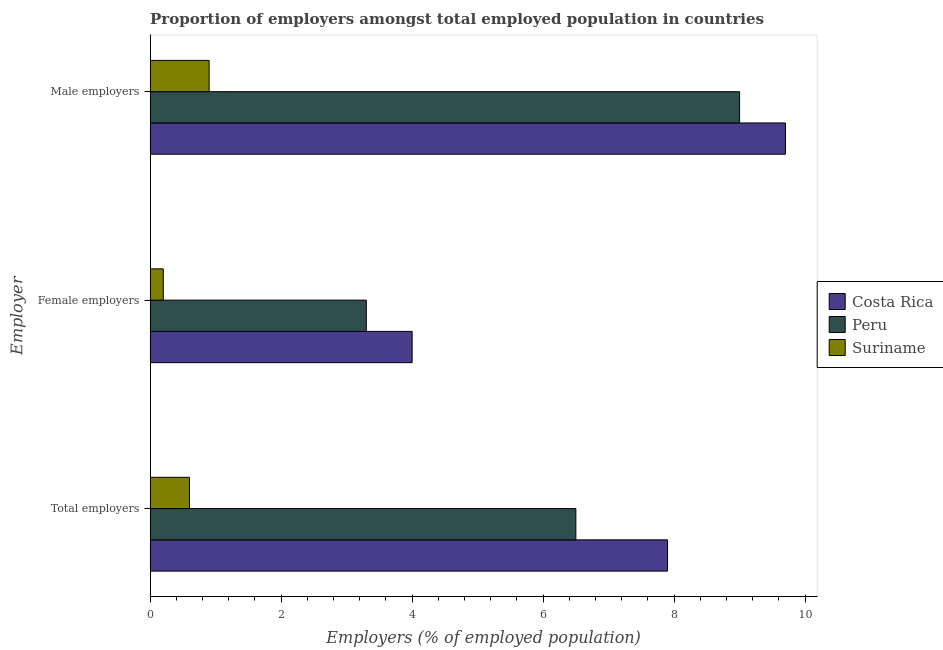How many different coloured bars are there?
Ensure brevity in your answer.  3. How many groups of bars are there?
Keep it short and to the point. 3. Are the number of bars per tick equal to the number of legend labels?
Make the answer very short. Yes. How many bars are there on the 3rd tick from the top?
Your answer should be very brief. 3. What is the label of the 3rd group of bars from the top?
Offer a very short reply. Total employers. Across all countries, what is the maximum percentage of total employers?
Provide a succinct answer. 7.9. Across all countries, what is the minimum percentage of female employers?
Provide a succinct answer. 0.2. In which country was the percentage of male employers maximum?
Ensure brevity in your answer.  Costa Rica. In which country was the percentage of male employers minimum?
Offer a very short reply. Suriname. What is the total percentage of male employers in the graph?
Offer a very short reply. 19.6. What is the difference between the percentage of total employers in Costa Rica and that in Peru?
Your answer should be compact. 1.4. What is the difference between the percentage of female employers in Peru and the percentage of male employers in Costa Rica?
Your answer should be compact. -6.4. What is the average percentage of female employers per country?
Offer a terse response. 2.5. What is the difference between the percentage of total employers and percentage of male employers in Peru?
Provide a short and direct response. -2.5. What is the ratio of the percentage of female employers in Suriname to that in Costa Rica?
Offer a terse response. 0.05. Is the difference between the percentage of female employers in Peru and Costa Rica greater than the difference between the percentage of male employers in Peru and Costa Rica?
Make the answer very short. No. What is the difference between the highest and the second highest percentage of total employers?
Your response must be concise. 1.4. What is the difference between the highest and the lowest percentage of male employers?
Provide a succinct answer. 8.8. What does the 1st bar from the top in Male employers represents?
Offer a very short reply. Suriname. Is it the case that in every country, the sum of the percentage of total employers and percentage of female employers is greater than the percentage of male employers?
Ensure brevity in your answer.  No. How many bars are there?
Provide a succinct answer. 9. Are the values on the major ticks of X-axis written in scientific E-notation?
Offer a very short reply. No. Does the graph contain any zero values?
Ensure brevity in your answer.  No. Does the graph contain grids?
Provide a succinct answer. No. Where does the legend appear in the graph?
Your response must be concise. Center right. How many legend labels are there?
Offer a very short reply. 3. What is the title of the graph?
Ensure brevity in your answer.  Proportion of employers amongst total employed population in countries. What is the label or title of the X-axis?
Ensure brevity in your answer.  Employers (% of employed population). What is the label or title of the Y-axis?
Offer a terse response. Employer. What is the Employers (% of employed population) in Costa Rica in Total employers?
Keep it short and to the point. 7.9. What is the Employers (% of employed population) in Peru in Total employers?
Make the answer very short. 6.5. What is the Employers (% of employed population) of Suriname in Total employers?
Make the answer very short. 0.6. What is the Employers (% of employed population) in Costa Rica in Female employers?
Your answer should be very brief. 4. What is the Employers (% of employed population) of Peru in Female employers?
Provide a short and direct response. 3.3. What is the Employers (% of employed population) in Suriname in Female employers?
Provide a succinct answer. 0.2. What is the Employers (% of employed population) of Costa Rica in Male employers?
Your response must be concise. 9.7. What is the Employers (% of employed population) of Peru in Male employers?
Give a very brief answer. 9. What is the Employers (% of employed population) of Suriname in Male employers?
Make the answer very short. 0.9. Across all Employer, what is the maximum Employers (% of employed population) in Costa Rica?
Your response must be concise. 9.7. Across all Employer, what is the maximum Employers (% of employed population) of Suriname?
Keep it short and to the point. 0.9. Across all Employer, what is the minimum Employers (% of employed population) in Peru?
Make the answer very short. 3.3. Across all Employer, what is the minimum Employers (% of employed population) in Suriname?
Provide a succinct answer. 0.2. What is the total Employers (% of employed population) of Costa Rica in the graph?
Offer a terse response. 21.6. What is the total Employers (% of employed population) of Suriname in the graph?
Provide a succinct answer. 1.7. What is the difference between the Employers (% of employed population) of Peru in Total employers and that in Male employers?
Your answer should be compact. -2.5. What is the difference between the Employers (% of employed population) in Suriname in Total employers and that in Male employers?
Make the answer very short. -0.3. What is the difference between the Employers (% of employed population) in Peru in Female employers and that in Male employers?
Make the answer very short. -5.7. What is the difference between the Employers (% of employed population) of Suriname in Female employers and that in Male employers?
Your answer should be very brief. -0.7. What is the difference between the Employers (% of employed population) of Peru in Total employers and the Employers (% of employed population) of Suriname in Female employers?
Ensure brevity in your answer.  6.3. What is the difference between the Employers (% of employed population) of Costa Rica in Total employers and the Employers (% of employed population) of Peru in Male employers?
Give a very brief answer. -1.1. What is the difference between the Employers (% of employed population) of Costa Rica in Total employers and the Employers (% of employed population) of Suriname in Male employers?
Offer a very short reply. 7. What is the difference between the Employers (% of employed population) in Costa Rica in Female employers and the Employers (% of employed population) in Suriname in Male employers?
Make the answer very short. 3.1. What is the difference between the Employers (% of employed population) of Peru in Female employers and the Employers (% of employed population) of Suriname in Male employers?
Give a very brief answer. 2.4. What is the average Employers (% of employed population) in Costa Rica per Employer?
Your response must be concise. 7.2. What is the average Employers (% of employed population) in Peru per Employer?
Make the answer very short. 6.27. What is the average Employers (% of employed population) in Suriname per Employer?
Your answer should be very brief. 0.57. What is the difference between the Employers (% of employed population) of Peru and Employers (% of employed population) of Suriname in Female employers?
Ensure brevity in your answer.  3.1. What is the difference between the Employers (% of employed population) in Costa Rica and Employers (% of employed population) in Peru in Male employers?
Ensure brevity in your answer.  0.7. What is the difference between the Employers (% of employed population) of Costa Rica and Employers (% of employed population) of Suriname in Male employers?
Keep it short and to the point. 8.8. What is the difference between the Employers (% of employed population) of Peru and Employers (% of employed population) of Suriname in Male employers?
Make the answer very short. 8.1. What is the ratio of the Employers (% of employed population) in Costa Rica in Total employers to that in Female employers?
Provide a succinct answer. 1.98. What is the ratio of the Employers (% of employed population) in Peru in Total employers to that in Female employers?
Offer a very short reply. 1.97. What is the ratio of the Employers (% of employed population) in Suriname in Total employers to that in Female employers?
Provide a succinct answer. 3. What is the ratio of the Employers (% of employed population) in Costa Rica in Total employers to that in Male employers?
Your response must be concise. 0.81. What is the ratio of the Employers (% of employed population) in Peru in Total employers to that in Male employers?
Give a very brief answer. 0.72. What is the ratio of the Employers (% of employed population) of Suriname in Total employers to that in Male employers?
Give a very brief answer. 0.67. What is the ratio of the Employers (% of employed population) in Costa Rica in Female employers to that in Male employers?
Your answer should be very brief. 0.41. What is the ratio of the Employers (% of employed population) in Peru in Female employers to that in Male employers?
Ensure brevity in your answer.  0.37. What is the ratio of the Employers (% of employed population) of Suriname in Female employers to that in Male employers?
Provide a succinct answer. 0.22. What is the difference between the highest and the second highest Employers (% of employed population) in Peru?
Your response must be concise. 2.5. What is the difference between the highest and the second highest Employers (% of employed population) in Suriname?
Your response must be concise. 0.3. What is the difference between the highest and the lowest Employers (% of employed population) in Suriname?
Give a very brief answer. 0.7. 